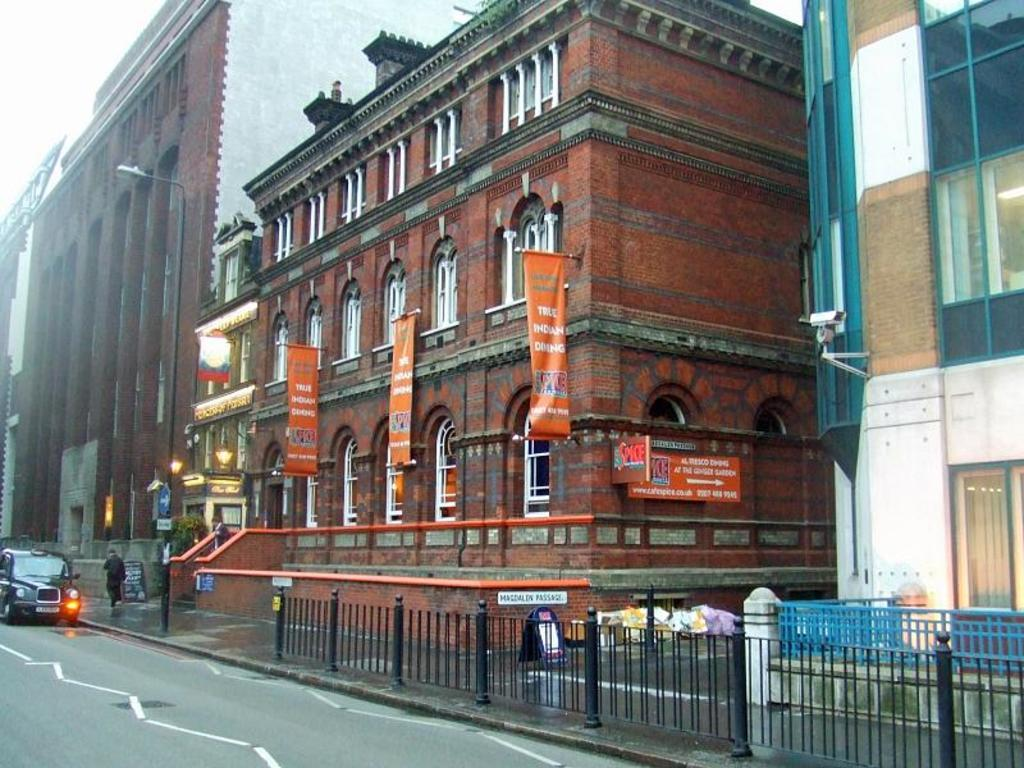What is the main subject of the image? There is a car on the road in the image. What is located beside the car? There is a metal fence beside the car. What can be seen in the background of the image? There are buildings and the sky visible in the background of the image. How does the car's mom react to the self-driving feature in the image? There is no mention of a car's mom or a self-driving feature in the image. 